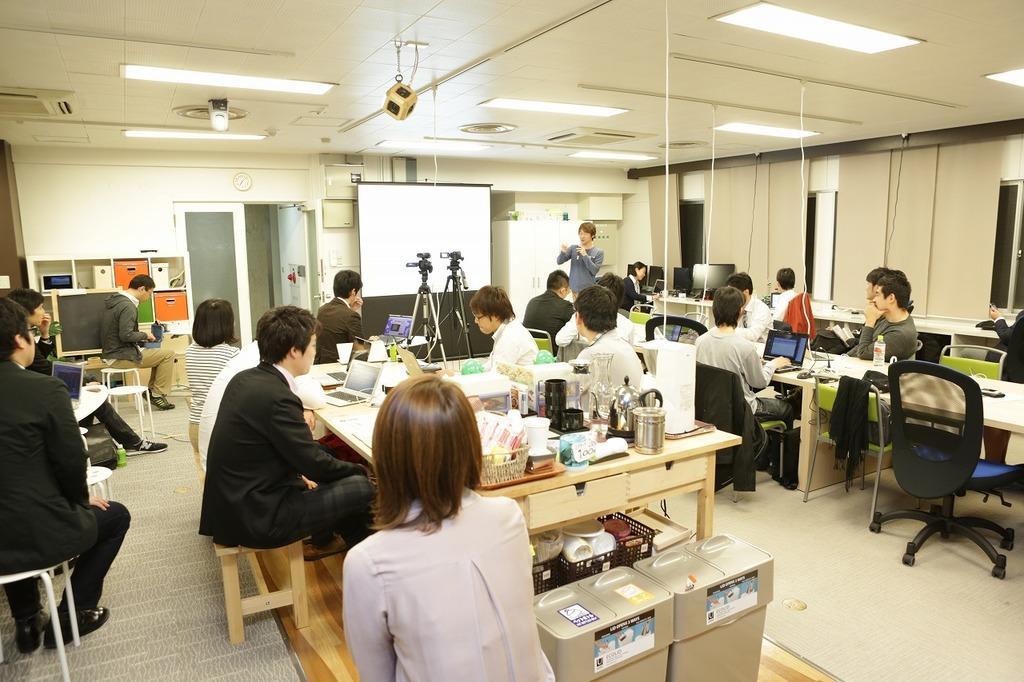In one or two sentences, can you explain what this image depicts? In this picture we observe many people sitting on the tables and a guy explaining all these on a projector and two cameras with stands are placed in front of the projector and there are many designer lights mounted to the roof. 